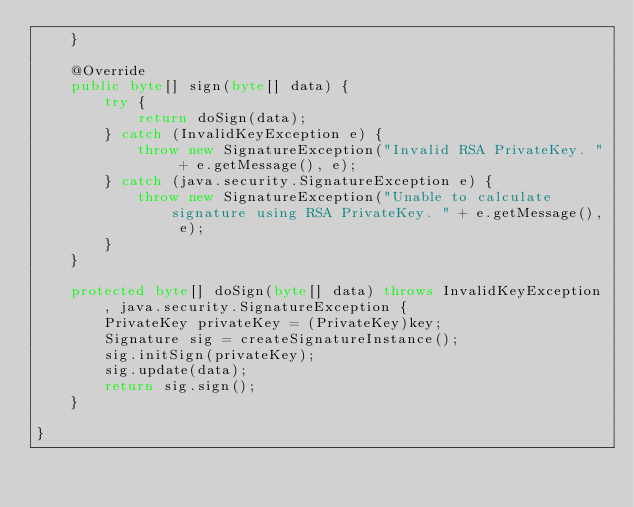Convert code to text. <code><loc_0><loc_0><loc_500><loc_500><_Java_>    }

    @Override
    public byte[] sign(byte[] data) {
        try {
            return doSign(data);
        } catch (InvalidKeyException e) {
            throw new SignatureException("Invalid RSA PrivateKey. " + e.getMessage(), e);
        } catch (java.security.SignatureException e) {
            throw new SignatureException("Unable to calculate signature using RSA PrivateKey. " + e.getMessage(), e);
        }
    }

    protected byte[] doSign(byte[] data) throws InvalidKeyException, java.security.SignatureException {
        PrivateKey privateKey = (PrivateKey)key;
        Signature sig = createSignatureInstance();
        sig.initSign(privateKey);
        sig.update(data);
        return sig.sign();
    }

}
</code> 